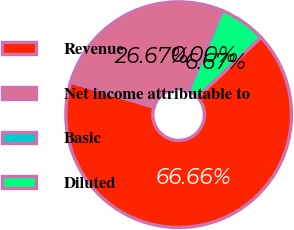<chart> <loc_0><loc_0><loc_500><loc_500><pie_chart><fcel>Revenue<fcel>Net income attributable to<fcel>Basic<fcel>Diluted<nl><fcel>66.67%<fcel>26.67%<fcel>0.0%<fcel>6.67%<nl></chart> 